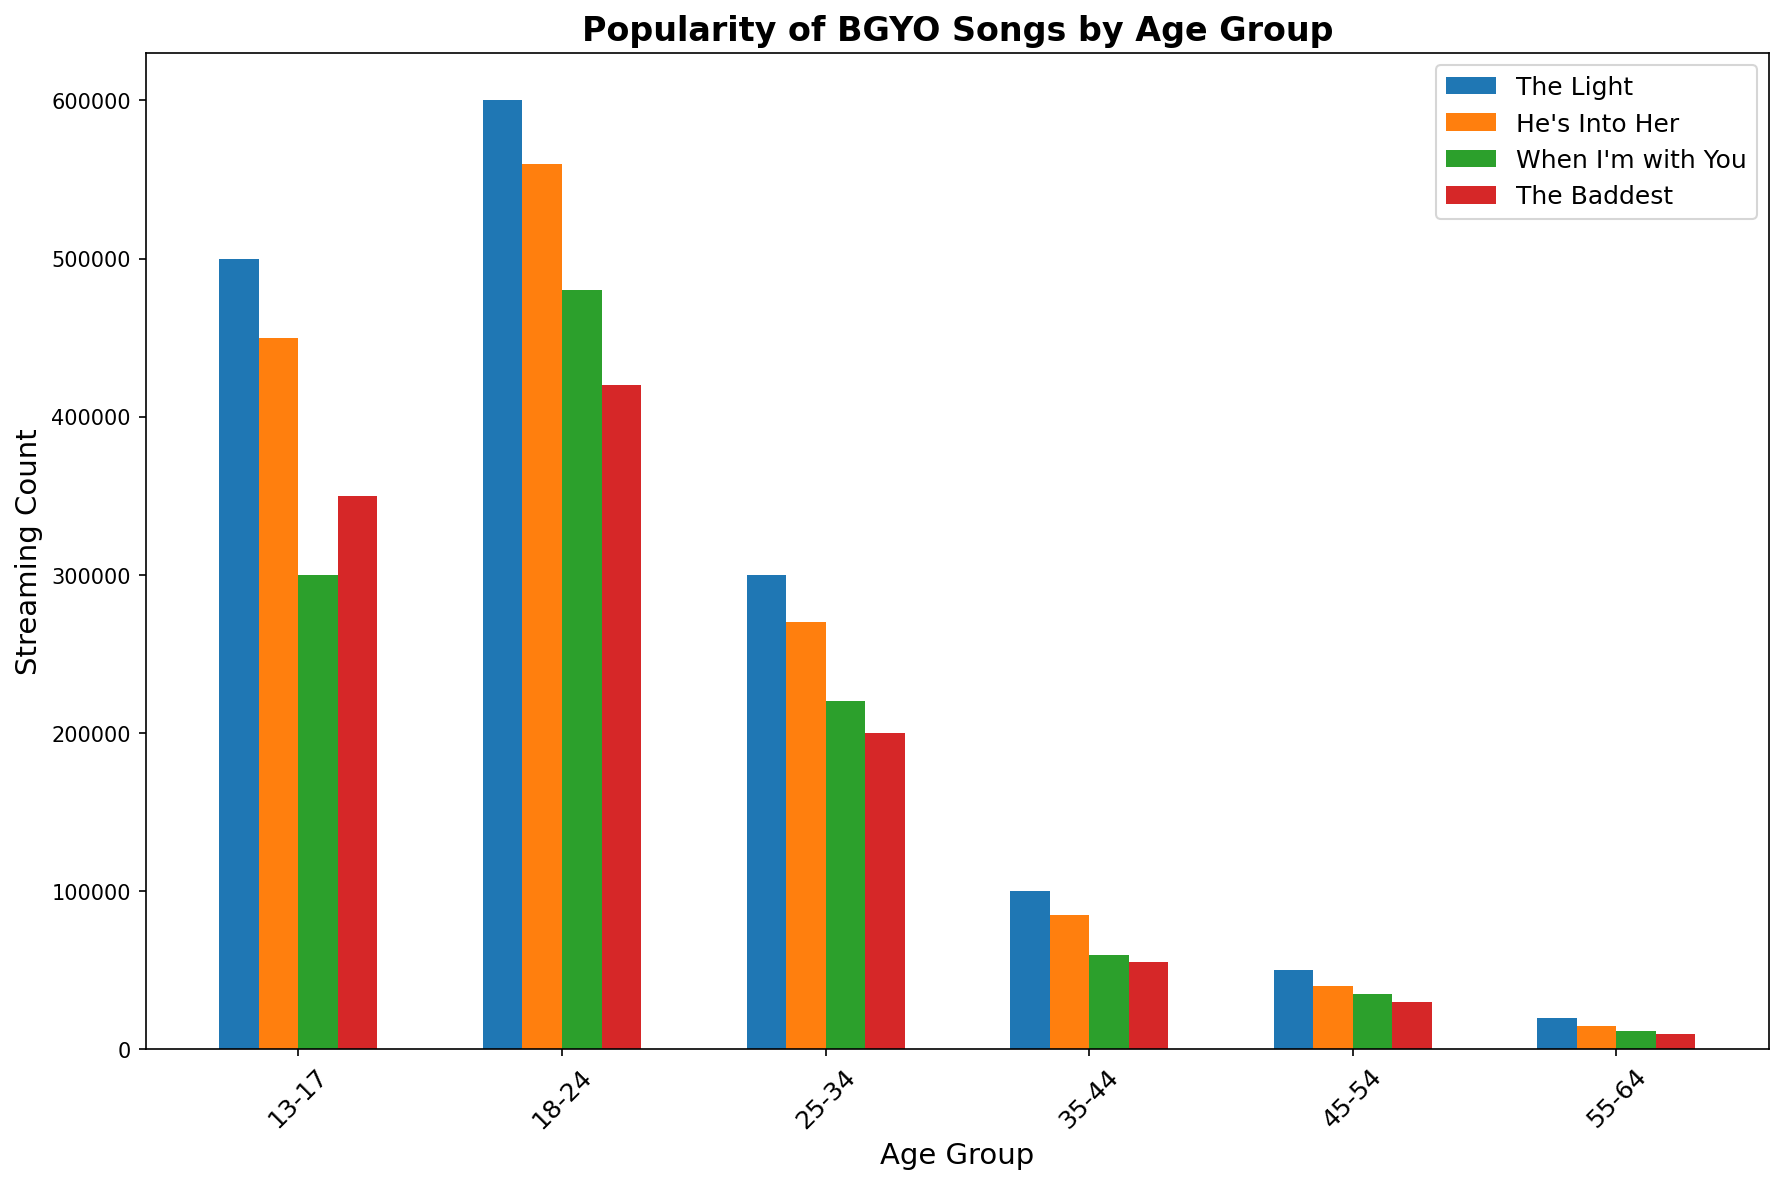Which age group has the highest streaming count for "The Light"? The bar representing "The Light" for each age group is tallest for the 18-24 age group.
Answer: 18-24 What's the combined streaming count for "He's Into Her" for the age groups 13-17 and 18-24? The streaming count for "He's Into Her" in the 13-17 age group is 450,000 and for the 18-24 age group, it's 560,000. Sum them up: 450,000 + 560,000 = 1,010,000.
Answer: 1,010,000 Which song is the least popular among the 45-54 age group? The shortest bar for the 45-54 age group represents "The Baddest" with a streaming count of 30,000.
Answer: The Baddest How much higher is the streaming count of "When I'm with You" in the 18-24 age group compared to the 35-44 age group? The streaming count for "When I'm with You" is 480,000 in the 18-24 age group and 60,000 in the 35-44 age group. The difference is 480,000 - 60,000 = 420,000.
Answer: 420,000 Which song has the most consistent streaming count across all age groups? By comparing the heights of the bars for each song across all age groups, "The Light" appears to be relatively the most consistent, having high streaming counts in each group.
Answer: The Light What is the average streaming count of "The Baddest" across all age groups? The streaming counts for "The Baddest" are 350,000, 420,000, 200,000, 55,000, 30,000, and 10,000. Summing them gives 350,000 + 420,000 + 200,000 + 55,000 + 30,000 + 10,000 = 1,065,000. Dividing by 6 (the number of age groups), the average is 1,065,000 / 6 = 177,500.
Answer: 177,500 How does the streaming count for "The Light" in the 18-24 age group compare to all other songs in the same age group? The streaming count for "The Light" is 600,000. Comparing to "He's Into Her" (560,000), "When I'm with You" (480,000), and "The Baddest" (420,000), "The Light" has the highest streaming count in the 18-24 age group.
Answer: Highest Which age group has the least total streaming counts summed across all songs? Sum the streaming counts for each age group: 13-17 group has 500,000 + 450,000 + 300,000 + 350,000 = 1,600,000; 18-24 group has 600,000 + 560,000 + 480,000 + 420,000 = 2,060,000; 25-34 group has 300,000 + 270,000 + 220,000 + 200,000 = 990,000; 35-44 group has 100,000 + 85,000 + 60,000 + 55,000 = 300,000; 45-54 group has 50,000 + 40,000 + 35,000 + 30,000 = 155,000; 55-64 group has 20,000 + 15,000 + 12,000 + 10,000 = 57,000. The 55-64 age group has the least total with 57,000.
Answer: 55-64 